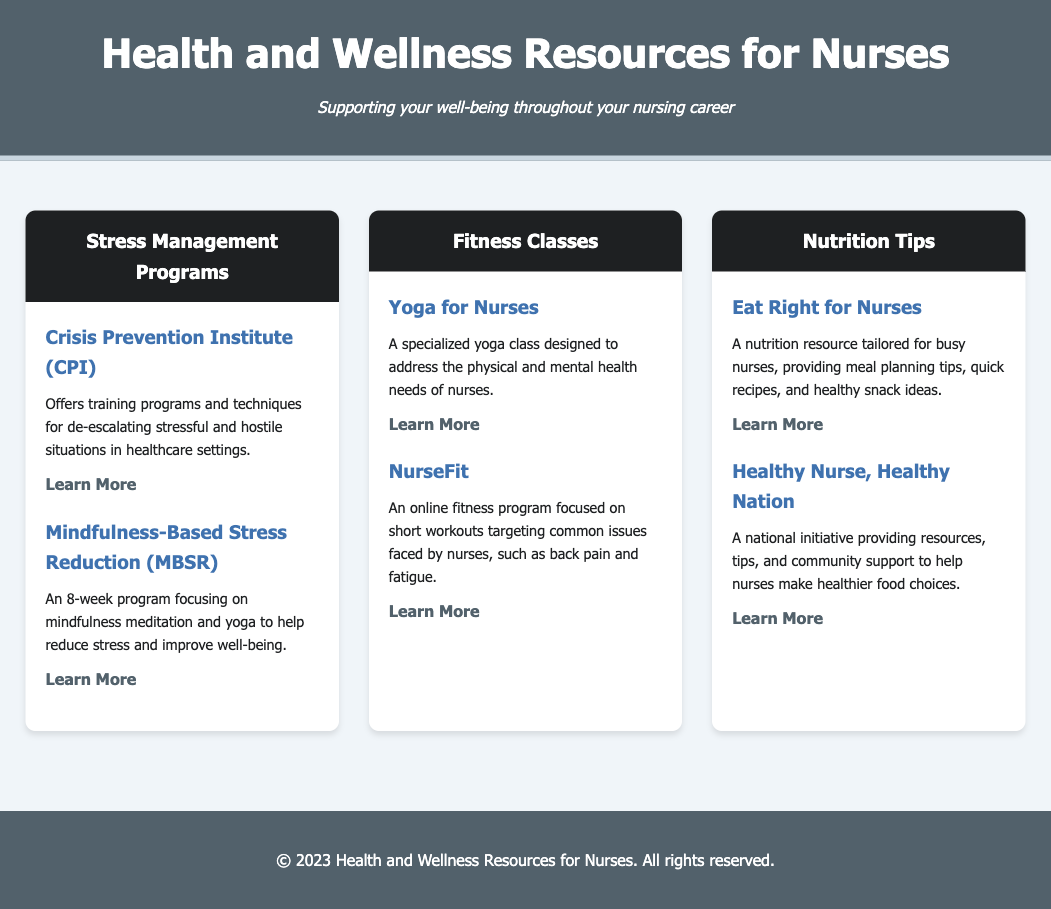What program offers techniques for de-escalating stressful situations? The document states that the Crisis Prevention Institute (CPI) offers training programs and techniques for de-escalating stressful and hostile situations in healthcare settings.
Answer: Crisis Prevention Institute (CPI) How long is the Mindfulness-Based Stress Reduction program? According to the document, the Mindfulness-Based Stress Reduction program is an 8-week program.
Answer: 8 weeks What specialized class is designed for nurses? The document mentions a specialized yoga class titled "Yoga for Nurses."
Answer: Yoga for Nurses What is the focus of the NurseFit program? The NurseFit program is focused on short workouts targeting common issues faced by nurses, such as back pain and fatigue.
Answer: Short workouts for back pain and fatigue What nutrition resource provides meal planning tips? The document refers to "Eat Right for Nurses" as the resource providing meal planning tips.
Answer: Eat Right for Nurses What is the aim of the Healthy Nurse, Healthy Nation initiative? The document states that the Healthy Nurse, Healthy Nation initiative aims to provide resources, tips, and community support to help nurses make healthier food choices.
Answer: Make healthier food choices Which program involves mindfulness meditation and yoga? The Mindfulness-Based Stress Reduction (MBSR) program involves mindfulness meditation and yoga to help reduce stress and improve well-being.
Answer: Mindfulness-Based Stress Reduction (MBSR) How many sections are in the menu? The menu has three sections: Stress Management Programs, Fitness Classes, and Nutrition Tips.
Answer: Three sections 